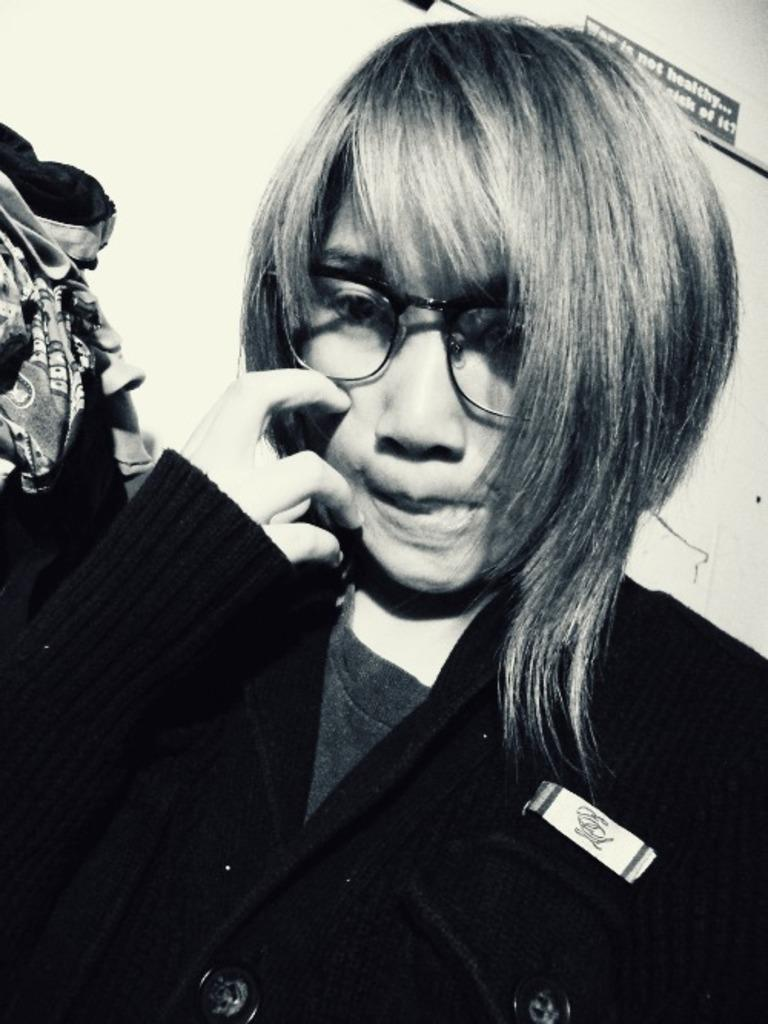Who is the main subject in the picture? There is a girl in the picture. What is the girl wearing in the picture? The girl is wearing a black sweater. Are there any accessories visible on the girl? Yes, the girl is wearing glasses (specs). What is the girl doing in the picture? The girl is posing for the camera. What can be seen in the background of the picture? There is a white wall in the background of the picture. What type of branch can be seen on the girl's face in the image? There is no branch visible on the girl's face in the image. What time of day is it in the image? The provided facts do not mention the time of day, so it cannot be determined from the image. 